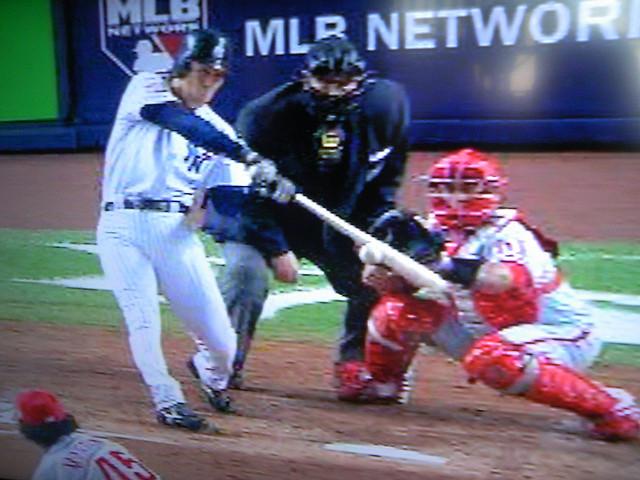Which game are they playing?
Answer briefly. Baseball. Is the batter going to hit the ball?
Short answer required. Yes. What team is the batter on?
Concise answer only. Yankees. 